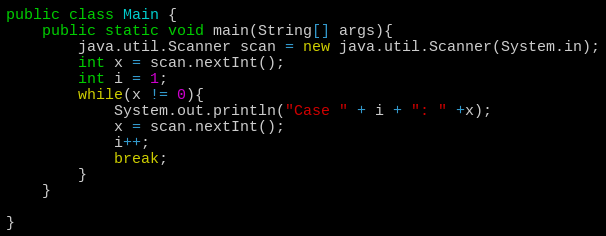<code> <loc_0><loc_0><loc_500><loc_500><_Java_>public class Main {
	public static void main(String[] args){
		java.util.Scanner scan = new java.util.Scanner(System.in);
		int x = scan.nextInt();
		int i = 1;
		while(x != 0){
			System.out.println("Case " + i + ": " +x);
			x = scan.nextInt();
			i++;
			break;
		}
	}

}</code> 